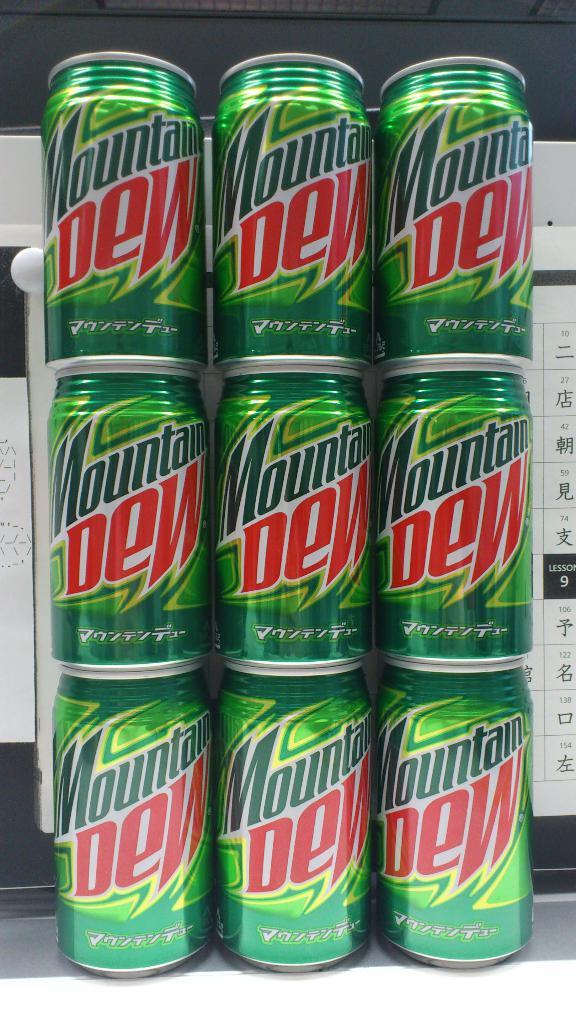What is the brand of soda?
Ensure brevity in your answer.  Mountain dew. 